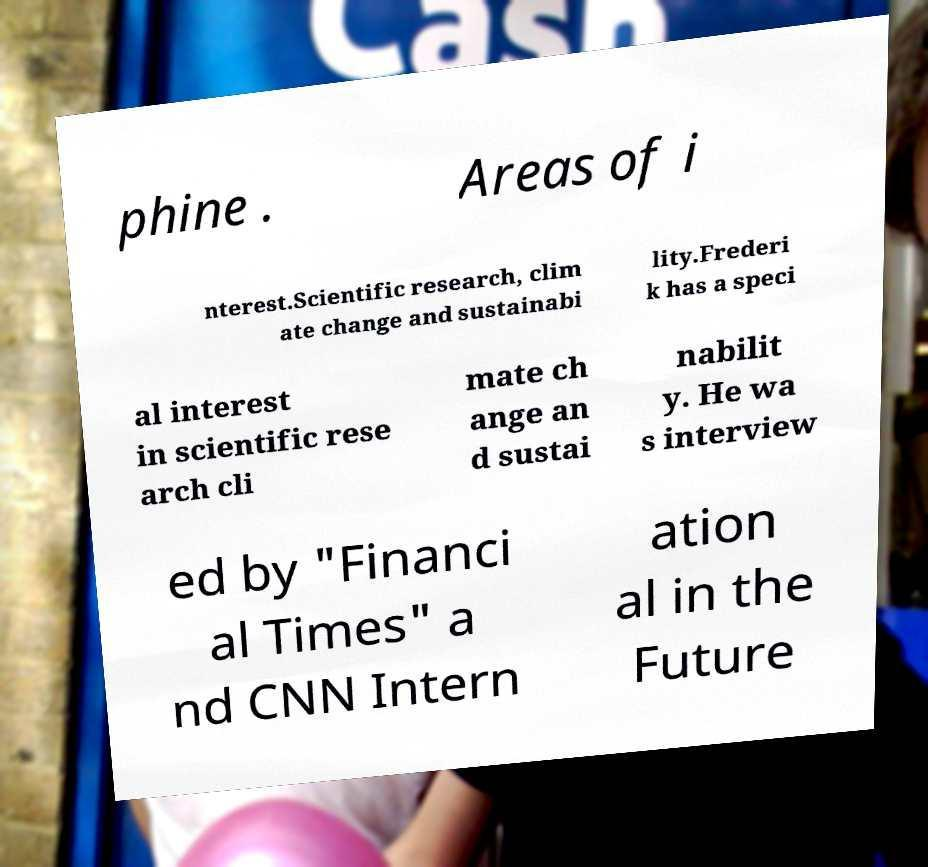Could you extract and type out the text from this image? phine . Areas of i nterest.Scientific research, clim ate change and sustainabi lity.Frederi k has a speci al interest in scientific rese arch cli mate ch ange an d sustai nabilit y. He wa s interview ed by "Financi al Times" a nd CNN Intern ation al in the Future 